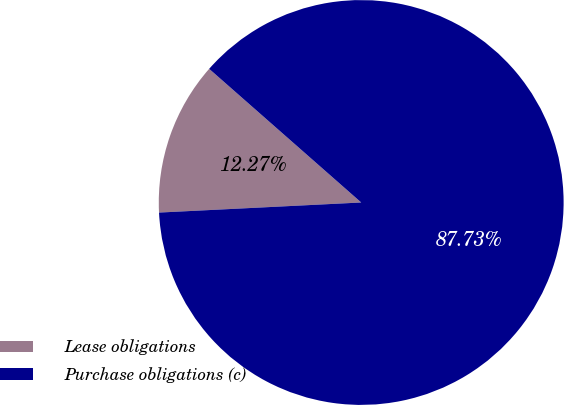<chart> <loc_0><loc_0><loc_500><loc_500><pie_chart><fcel>Lease obligations<fcel>Purchase obligations (c)<nl><fcel>12.27%<fcel>87.73%<nl></chart> 